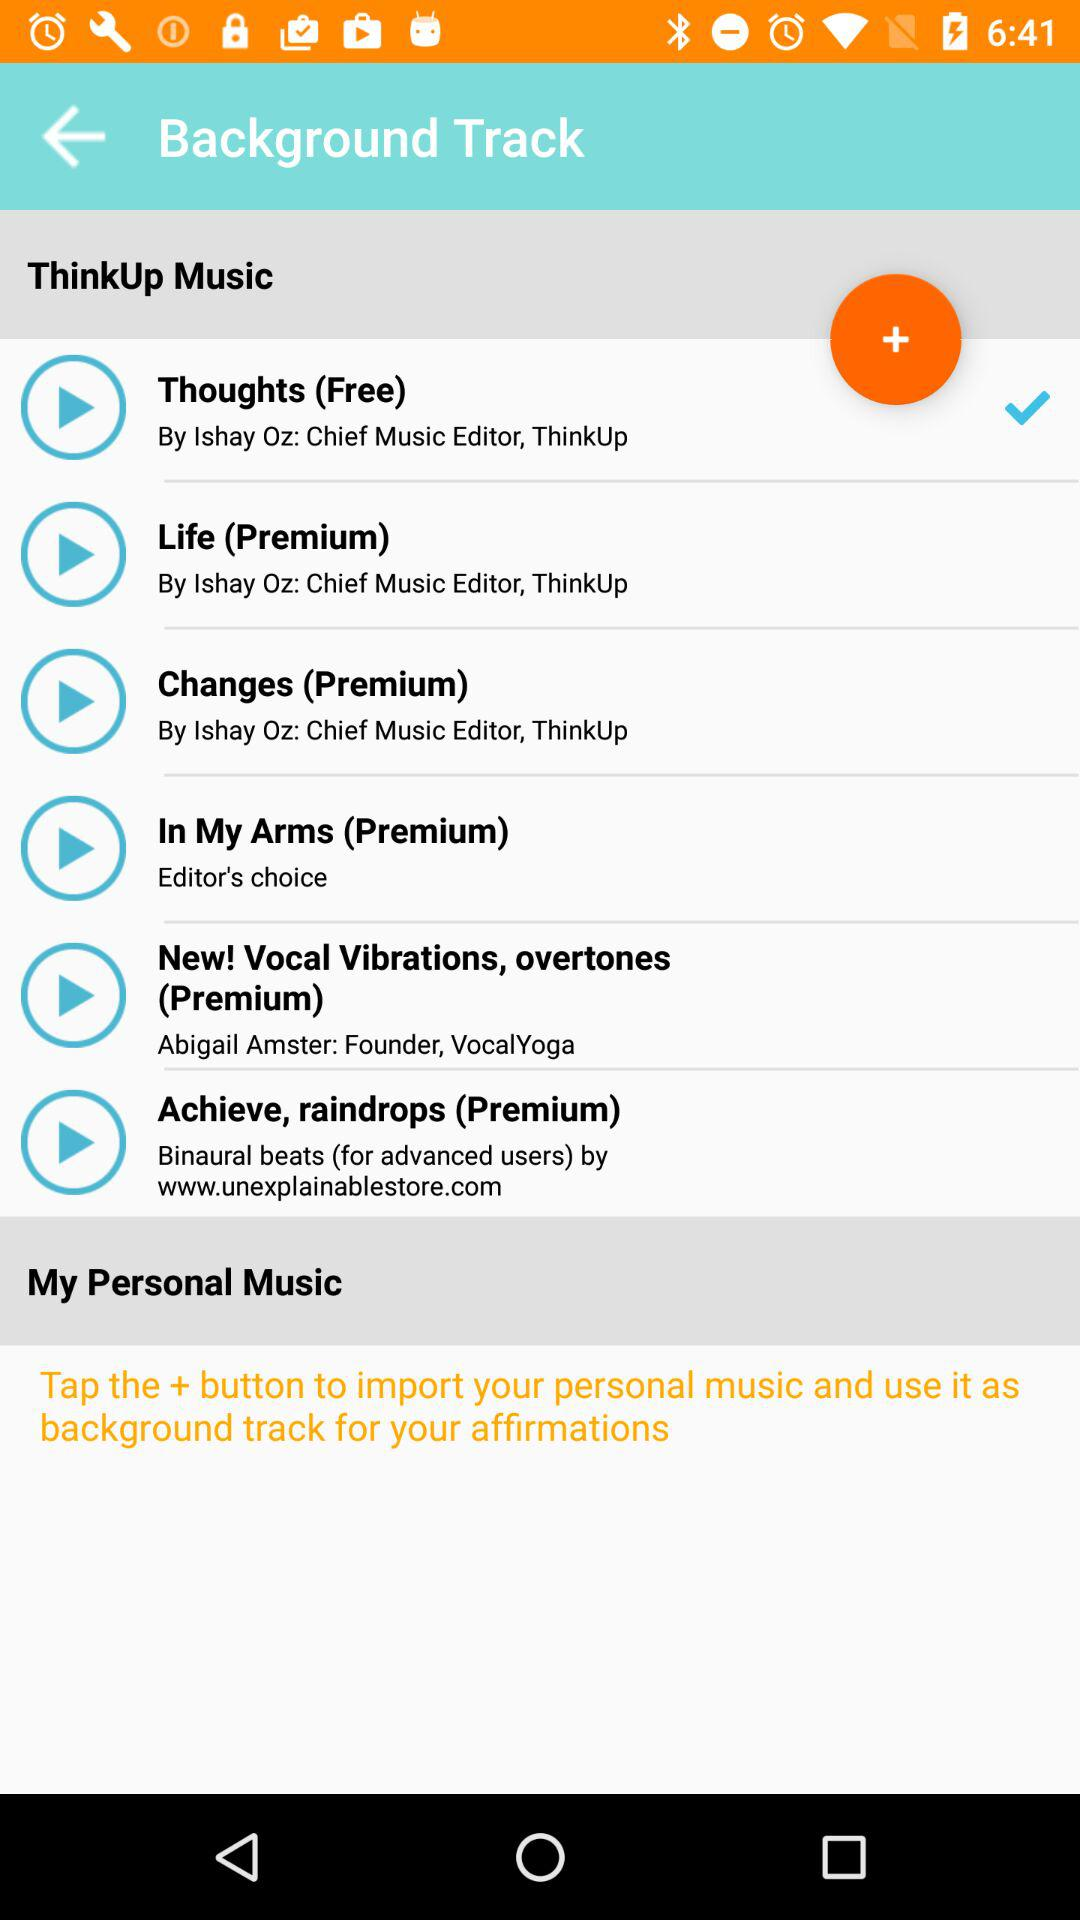What is the name of the singer of the song "Thoughts"? The name of the singer is Ishay Oz. 